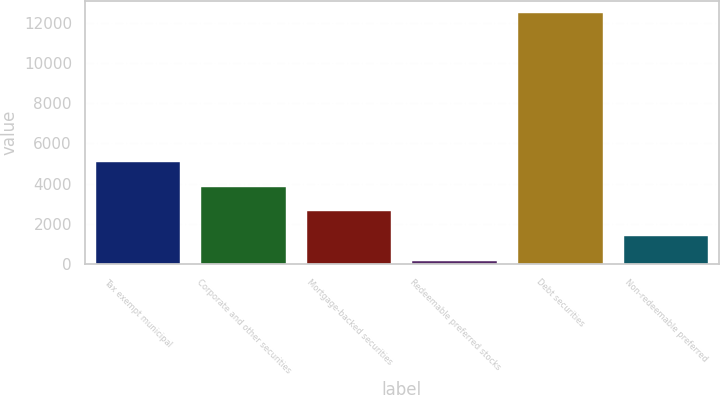Convert chart. <chart><loc_0><loc_0><loc_500><loc_500><bar_chart><fcel>Tax exempt municipal<fcel>Corporate and other securities<fcel>Mortgage-backed securities<fcel>Redeemable preferred stocks<fcel>Debt securities<fcel>Non-redeemable preferred<nl><fcel>5087.2<fcel>3857.9<fcel>2628.6<fcel>170<fcel>12463<fcel>1399.3<nl></chart> 